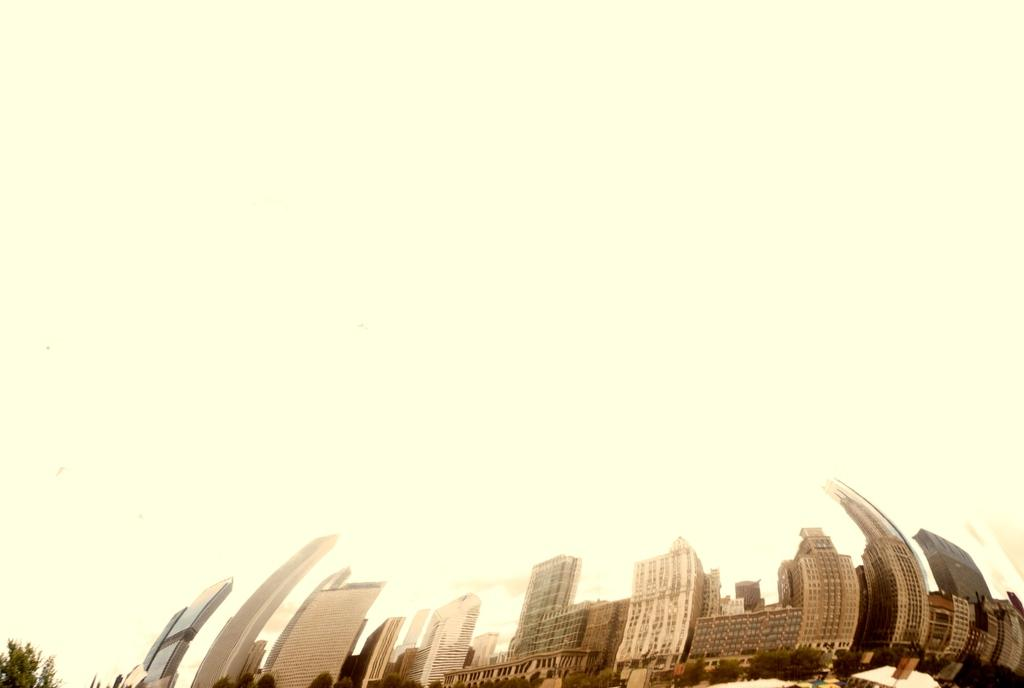What types of structures are located in the front of the image? There are buildings in the front of the image. What type of vegetation is also present in the front of the image? There are trees in the front of the image. Can you see a gun being used by the giants in the image? There are no giants or guns present in the image. Is there a boat visible in the image? There is no boat present in the image. 